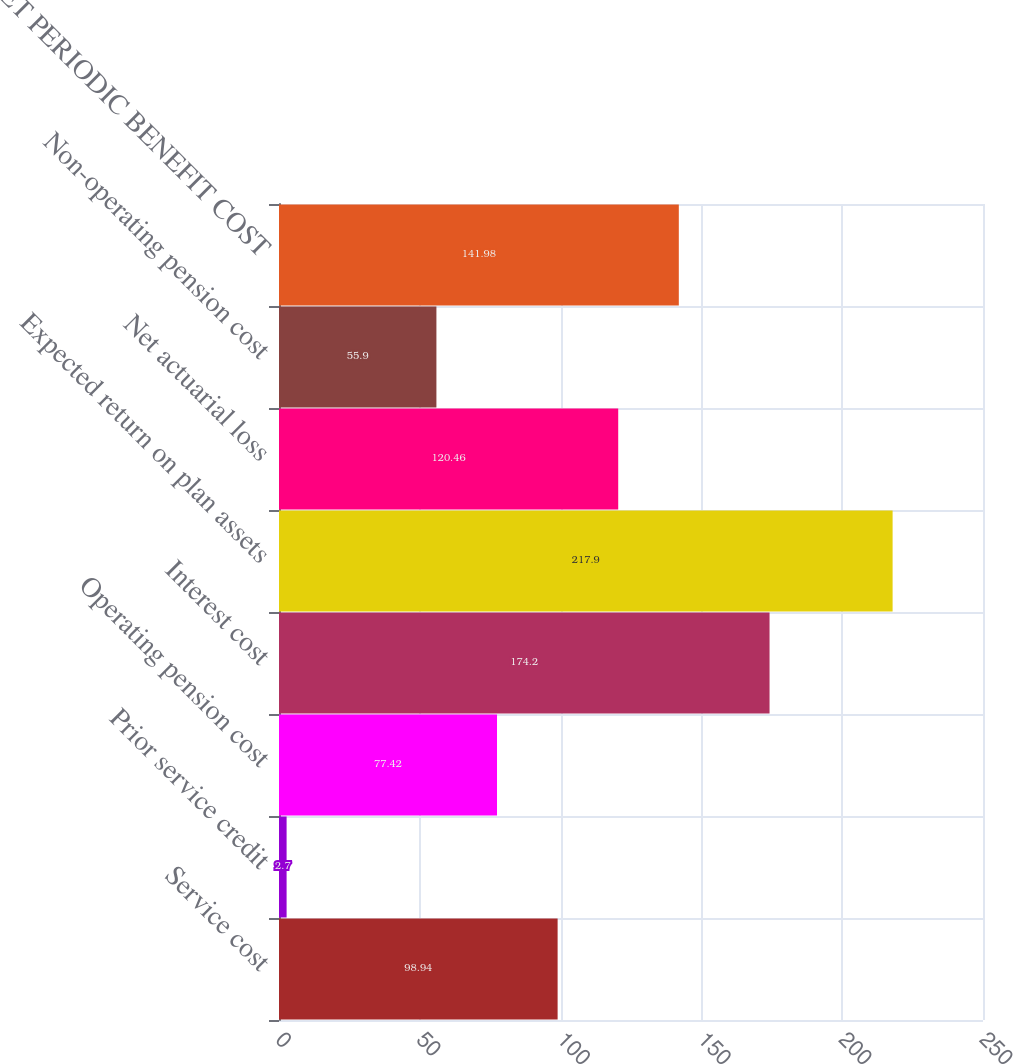Convert chart to OTSL. <chart><loc_0><loc_0><loc_500><loc_500><bar_chart><fcel>Service cost<fcel>Prior service credit<fcel>Operating pension cost<fcel>Interest cost<fcel>Expected return on plan assets<fcel>Net actuarial loss<fcel>Non-operating pension cost<fcel>NET PERIODIC BENEFIT COST<nl><fcel>98.94<fcel>2.7<fcel>77.42<fcel>174.2<fcel>217.9<fcel>120.46<fcel>55.9<fcel>141.98<nl></chart> 